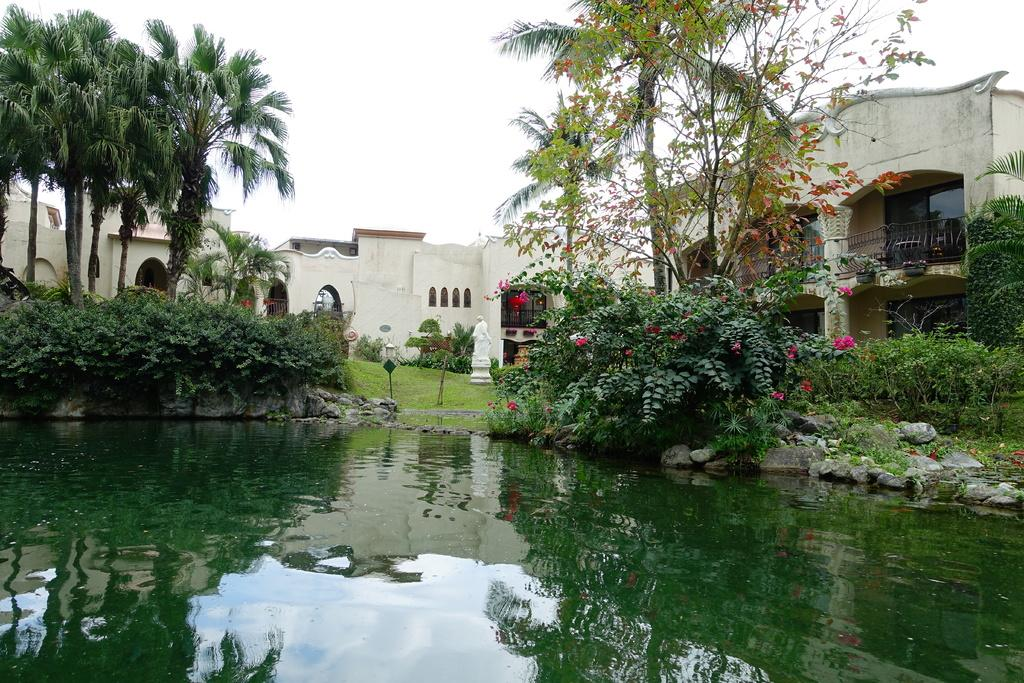What type of natural elements can be seen in the image? There are trees and plants visible in the image. What type of man-made structures can be seen in the image? There are buildings, poles, and railings visible in the image. What additional feature can be found in the image? There is a statue in the image. What is visible at the bottom of the image? There is water visible at the bottom of the image, with rocks visible within it. What type of bell can be heard ringing in the image? There is no bell present in the image, and therefore no sound can be heard. What type of animals can be seen at the zoo in the image? There is no zoo present in the image, and therefore no animals can be seen. 